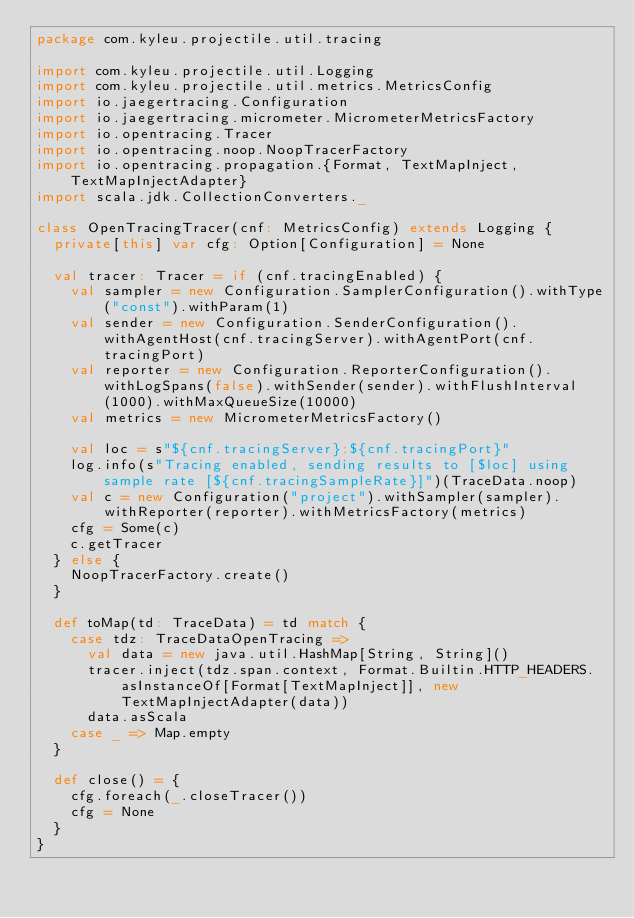<code> <loc_0><loc_0><loc_500><loc_500><_Scala_>package com.kyleu.projectile.util.tracing

import com.kyleu.projectile.util.Logging
import com.kyleu.projectile.util.metrics.MetricsConfig
import io.jaegertracing.Configuration
import io.jaegertracing.micrometer.MicrometerMetricsFactory
import io.opentracing.Tracer
import io.opentracing.noop.NoopTracerFactory
import io.opentracing.propagation.{Format, TextMapInject, TextMapInjectAdapter}
import scala.jdk.CollectionConverters._

class OpenTracingTracer(cnf: MetricsConfig) extends Logging {
  private[this] var cfg: Option[Configuration] = None

  val tracer: Tracer = if (cnf.tracingEnabled) {
    val sampler = new Configuration.SamplerConfiguration().withType("const").withParam(1)
    val sender = new Configuration.SenderConfiguration().withAgentHost(cnf.tracingServer).withAgentPort(cnf.tracingPort)
    val reporter = new Configuration.ReporterConfiguration().withLogSpans(false).withSender(sender).withFlushInterval(1000).withMaxQueueSize(10000)
    val metrics = new MicrometerMetricsFactory()

    val loc = s"${cnf.tracingServer}:${cnf.tracingPort}"
    log.info(s"Tracing enabled, sending results to [$loc] using sample rate [${cnf.tracingSampleRate}]")(TraceData.noop)
    val c = new Configuration("project").withSampler(sampler).withReporter(reporter).withMetricsFactory(metrics)
    cfg = Some(c)
    c.getTracer
  } else {
    NoopTracerFactory.create()
  }

  def toMap(td: TraceData) = td match {
    case tdz: TraceDataOpenTracing =>
      val data = new java.util.HashMap[String, String]()
      tracer.inject(tdz.span.context, Format.Builtin.HTTP_HEADERS.asInstanceOf[Format[TextMapInject]], new TextMapInjectAdapter(data))
      data.asScala
    case _ => Map.empty
  }

  def close() = {
    cfg.foreach(_.closeTracer())
    cfg = None
  }
}
</code> 